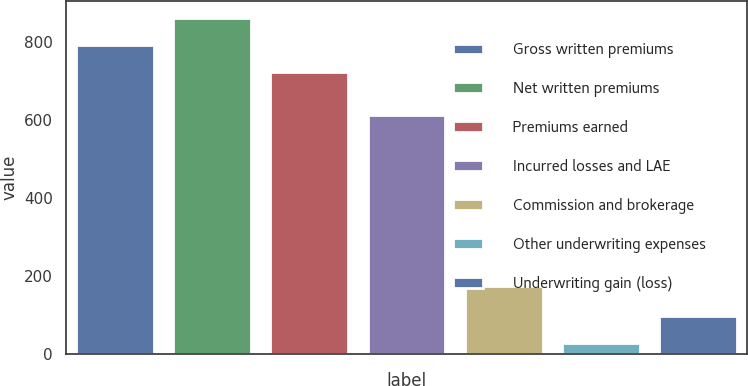Convert chart to OTSL. <chart><loc_0><loc_0><loc_500><loc_500><bar_chart><fcel>Gross written premiums<fcel>Net written premiums<fcel>Premiums earned<fcel>Incurred losses and LAE<fcel>Commission and brokerage<fcel>Other underwriting expenses<fcel>Underwriting gain (loss)<nl><fcel>792.92<fcel>862.84<fcel>723<fcel>613.9<fcel>174<fcel>26.3<fcel>96.22<nl></chart> 